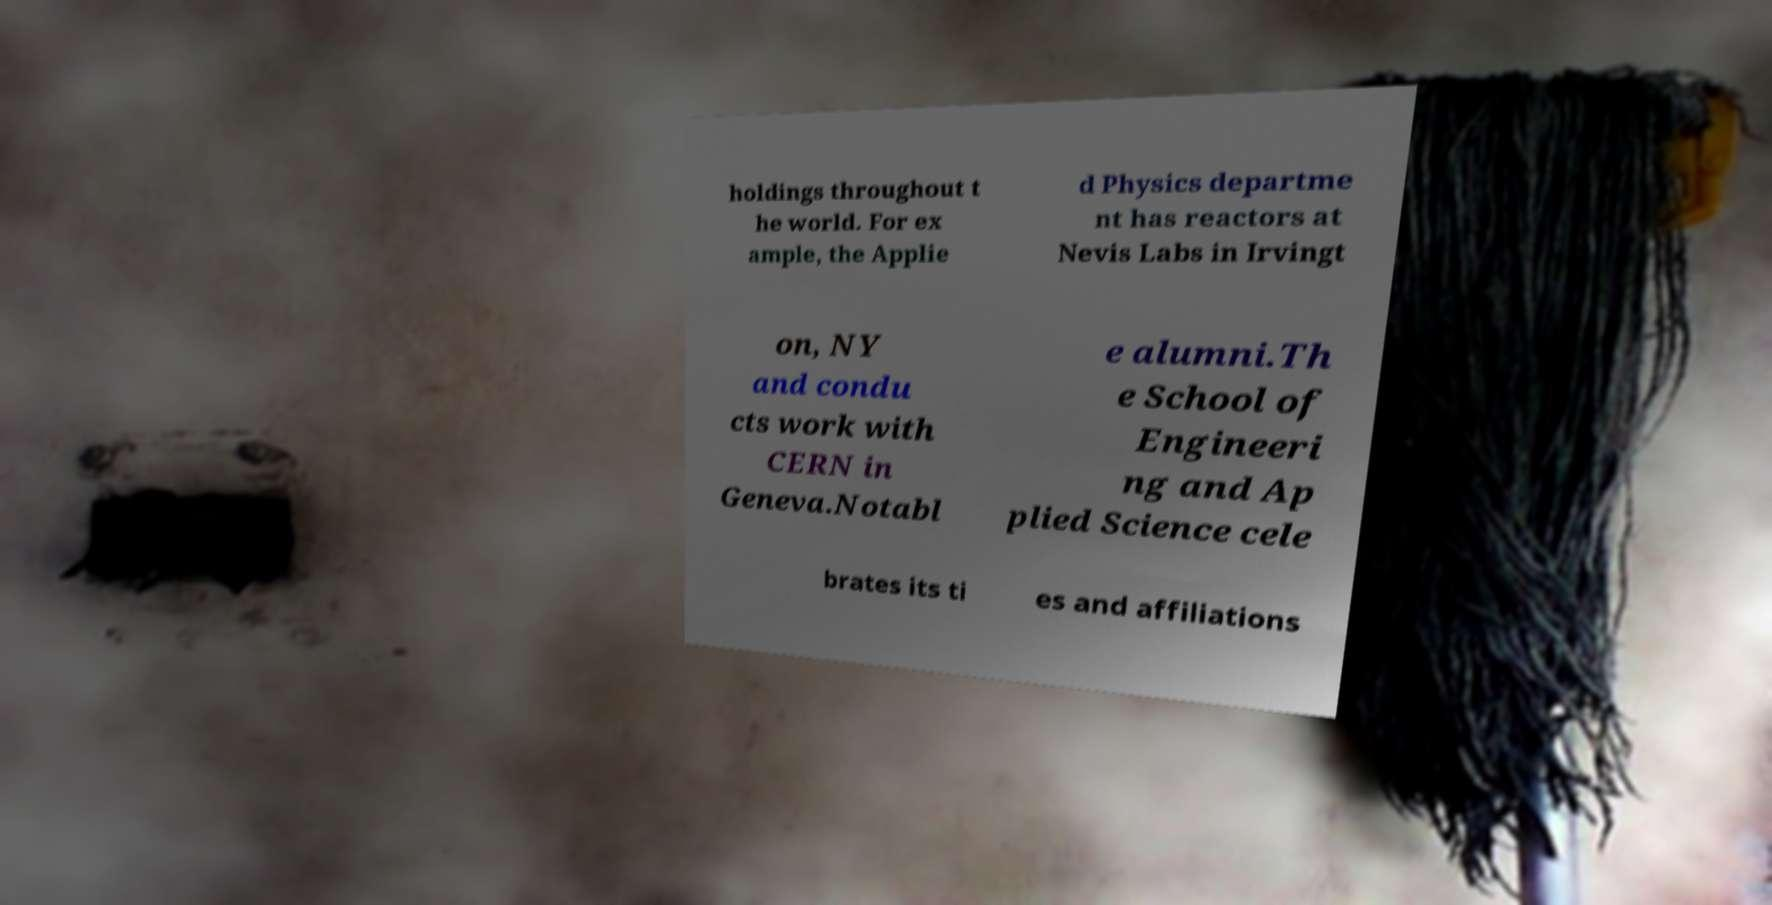Could you extract and type out the text from this image? holdings throughout t he world. For ex ample, the Applie d Physics departme nt has reactors at Nevis Labs in Irvingt on, NY and condu cts work with CERN in Geneva.Notabl e alumni.Th e School of Engineeri ng and Ap plied Science cele brates its ti es and affiliations 